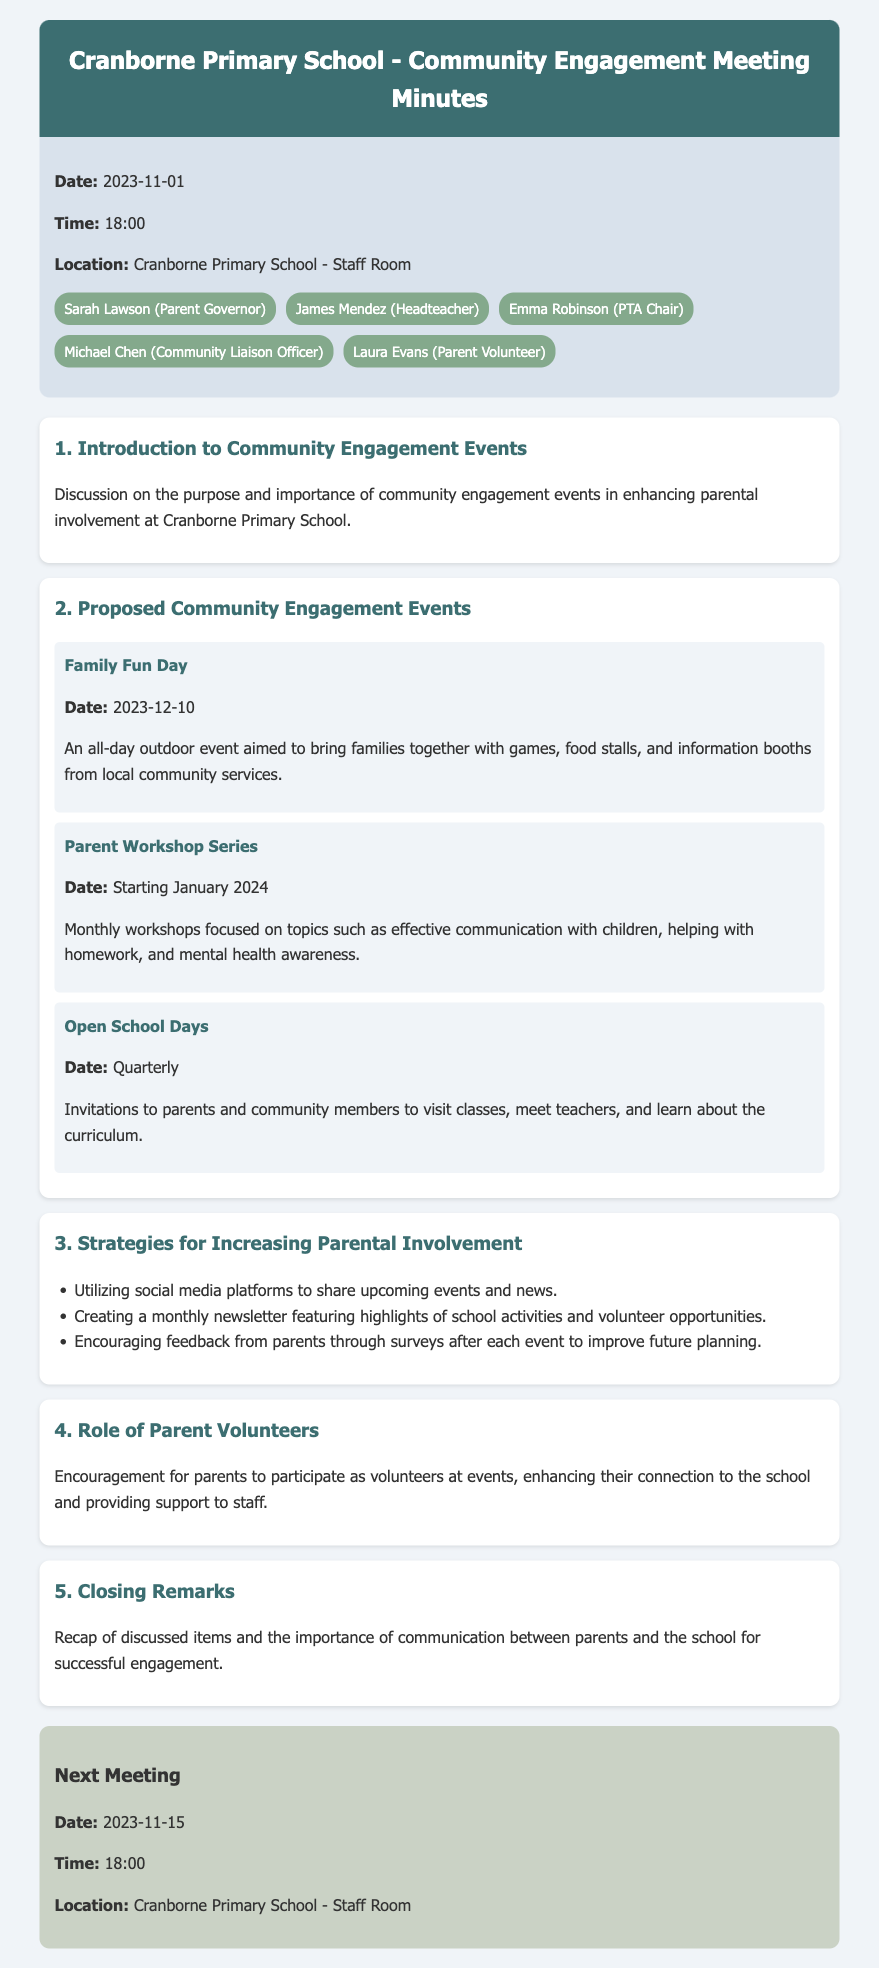What is the date of the Family Fun Day? The Family Fun Day is specifically scheduled for December 10, 2023, as mentioned in the document.
Answer: December 10, 2023 Who is the Headteacher of Cranborne Primary School? The meeting minutes provide the name of the Headteacher, which is James Mendez.
Answer: James Mendez What type of events are proposed to enhance parental involvement? The document lists several types of events that have been proposed, including Family Fun Day, Parent Workshop Series, and Open School Days.
Answer: Family Fun Day, Parent Workshop Series, Open School Days When is the next meeting scheduled? The minutes state that the next meeting will occur on November 15, 2023 at 18:00.
Answer: November 15, 2023 What strategies are suggested for increasing parental involvement? The document lists multiple strategies such as utilizing social media, creating a monthly newsletter, and encouraging feedback from parents.
Answer: Utilizing social media, monthly newsletter, encouraging feedback Why is it important for parents to volunteer at events? The agenda notes a specific encouragement for parents to volunteer, highlighting the benefits of connection to the school and support to staff.
Answer: Connection to the school, support to staff 